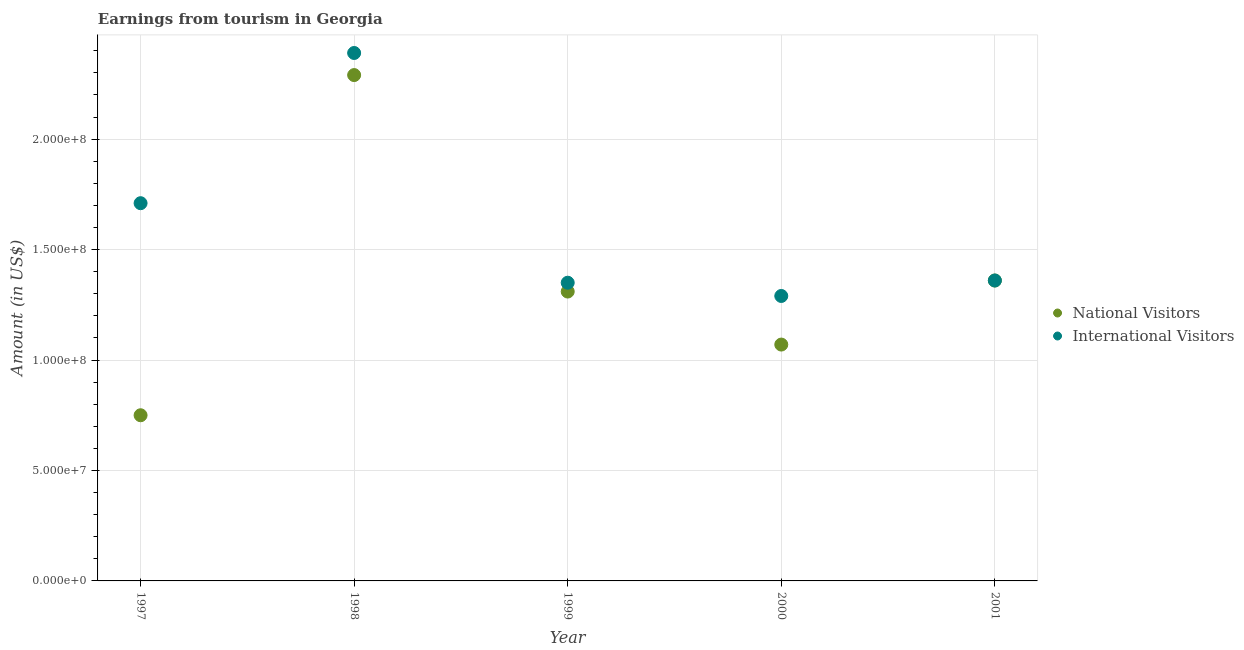How many different coloured dotlines are there?
Ensure brevity in your answer.  2. What is the amount earned from national visitors in 1999?
Give a very brief answer. 1.31e+08. Across all years, what is the maximum amount earned from national visitors?
Provide a succinct answer. 2.29e+08. Across all years, what is the minimum amount earned from international visitors?
Provide a succinct answer. 1.29e+08. In which year was the amount earned from international visitors maximum?
Your answer should be very brief. 1998. What is the total amount earned from international visitors in the graph?
Offer a very short reply. 8.10e+08. What is the difference between the amount earned from national visitors in 1997 and that in 2001?
Offer a very short reply. -6.10e+07. What is the difference between the amount earned from national visitors in 1999 and the amount earned from international visitors in 2000?
Keep it short and to the point. 2.00e+06. What is the average amount earned from national visitors per year?
Provide a short and direct response. 1.36e+08. In the year 1999, what is the difference between the amount earned from national visitors and amount earned from international visitors?
Ensure brevity in your answer.  -4.00e+06. What is the ratio of the amount earned from international visitors in 1997 to that in 1999?
Your response must be concise. 1.27. Is the difference between the amount earned from national visitors in 1997 and 1998 greater than the difference between the amount earned from international visitors in 1997 and 1998?
Ensure brevity in your answer.  No. What is the difference between the highest and the second highest amount earned from national visitors?
Your answer should be very brief. 9.30e+07. What is the difference between the highest and the lowest amount earned from international visitors?
Your answer should be very brief. 1.10e+08. In how many years, is the amount earned from international visitors greater than the average amount earned from international visitors taken over all years?
Provide a short and direct response. 2. Does the amount earned from national visitors monotonically increase over the years?
Offer a terse response. No. Is the amount earned from national visitors strictly greater than the amount earned from international visitors over the years?
Your response must be concise. No. Does the graph contain any zero values?
Provide a succinct answer. No. Where does the legend appear in the graph?
Your answer should be compact. Center right. What is the title of the graph?
Offer a very short reply. Earnings from tourism in Georgia. What is the label or title of the X-axis?
Offer a very short reply. Year. What is the Amount (in US$) in National Visitors in 1997?
Make the answer very short. 7.50e+07. What is the Amount (in US$) of International Visitors in 1997?
Provide a succinct answer. 1.71e+08. What is the Amount (in US$) in National Visitors in 1998?
Keep it short and to the point. 2.29e+08. What is the Amount (in US$) of International Visitors in 1998?
Keep it short and to the point. 2.39e+08. What is the Amount (in US$) in National Visitors in 1999?
Ensure brevity in your answer.  1.31e+08. What is the Amount (in US$) in International Visitors in 1999?
Keep it short and to the point. 1.35e+08. What is the Amount (in US$) of National Visitors in 2000?
Ensure brevity in your answer.  1.07e+08. What is the Amount (in US$) of International Visitors in 2000?
Your answer should be compact. 1.29e+08. What is the Amount (in US$) of National Visitors in 2001?
Your answer should be compact. 1.36e+08. What is the Amount (in US$) of International Visitors in 2001?
Your answer should be very brief. 1.36e+08. Across all years, what is the maximum Amount (in US$) in National Visitors?
Your response must be concise. 2.29e+08. Across all years, what is the maximum Amount (in US$) of International Visitors?
Offer a very short reply. 2.39e+08. Across all years, what is the minimum Amount (in US$) in National Visitors?
Your response must be concise. 7.50e+07. Across all years, what is the minimum Amount (in US$) in International Visitors?
Ensure brevity in your answer.  1.29e+08. What is the total Amount (in US$) of National Visitors in the graph?
Ensure brevity in your answer.  6.78e+08. What is the total Amount (in US$) in International Visitors in the graph?
Keep it short and to the point. 8.10e+08. What is the difference between the Amount (in US$) of National Visitors in 1997 and that in 1998?
Provide a short and direct response. -1.54e+08. What is the difference between the Amount (in US$) in International Visitors in 1997 and that in 1998?
Your answer should be very brief. -6.80e+07. What is the difference between the Amount (in US$) of National Visitors in 1997 and that in 1999?
Keep it short and to the point. -5.60e+07. What is the difference between the Amount (in US$) in International Visitors in 1997 and that in 1999?
Ensure brevity in your answer.  3.60e+07. What is the difference between the Amount (in US$) in National Visitors in 1997 and that in 2000?
Give a very brief answer. -3.20e+07. What is the difference between the Amount (in US$) in International Visitors in 1997 and that in 2000?
Offer a terse response. 4.20e+07. What is the difference between the Amount (in US$) in National Visitors in 1997 and that in 2001?
Keep it short and to the point. -6.10e+07. What is the difference between the Amount (in US$) in International Visitors in 1997 and that in 2001?
Keep it short and to the point. 3.50e+07. What is the difference between the Amount (in US$) in National Visitors in 1998 and that in 1999?
Ensure brevity in your answer.  9.80e+07. What is the difference between the Amount (in US$) of International Visitors in 1998 and that in 1999?
Provide a succinct answer. 1.04e+08. What is the difference between the Amount (in US$) of National Visitors in 1998 and that in 2000?
Ensure brevity in your answer.  1.22e+08. What is the difference between the Amount (in US$) of International Visitors in 1998 and that in 2000?
Offer a very short reply. 1.10e+08. What is the difference between the Amount (in US$) in National Visitors in 1998 and that in 2001?
Offer a terse response. 9.30e+07. What is the difference between the Amount (in US$) of International Visitors in 1998 and that in 2001?
Make the answer very short. 1.03e+08. What is the difference between the Amount (in US$) in National Visitors in 1999 and that in 2000?
Offer a very short reply. 2.40e+07. What is the difference between the Amount (in US$) in National Visitors in 1999 and that in 2001?
Give a very brief answer. -5.00e+06. What is the difference between the Amount (in US$) in International Visitors in 1999 and that in 2001?
Offer a very short reply. -1.00e+06. What is the difference between the Amount (in US$) in National Visitors in 2000 and that in 2001?
Provide a short and direct response. -2.90e+07. What is the difference between the Amount (in US$) of International Visitors in 2000 and that in 2001?
Offer a very short reply. -7.00e+06. What is the difference between the Amount (in US$) in National Visitors in 1997 and the Amount (in US$) in International Visitors in 1998?
Make the answer very short. -1.64e+08. What is the difference between the Amount (in US$) in National Visitors in 1997 and the Amount (in US$) in International Visitors in 1999?
Offer a very short reply. -6.00e+07. What is the difference between the Amount (in US$) of National Visitors in 1997 and the Amount (in US$) of International Visitors in 2000?
Your answer should be compact. -5.40e+07. What is the difference between the Amount (in US$) in National Visitors in 1997 and the Amount (in US$) in International Visitors in 2001?
Make the answer very short. -6.10e+07. What is the difference between the Amount (in US$) of National Visitors in 1998 and the Amount (in US$) of International Visitors in 1999?
Ensure brevity in your answer.  9.40e+07. What is the difference between the Amount (in US$) in National Visitors in 1998 and the Amount (in US$) in International Visitors in 2001?
Provide a succinct answer. 9.30e+07. What is the difference between the Amount (in US$) of National Visitors in 1999 and the Amount (in US$) of International Visitors in 2001?
Offer a very short reply. -5.00e+06. What is the difference between the Amount (in US$) of National Visitors in 2000 and the Amount (in US$) of International Visitors in 2001?
Keep it short and to the point. -2.90e+07. What is the average Amount (in US$) in National Visitors per year?
Your response must be concise. 1.36e+08. What is the average Amount (in US$) of International Visitors per year?
Keep it short and to the point. 1.62e+08. In the year 1997, what is the difference between the Amount (in US$) in National Visitors and Amount (in US$) in International Visitors?
Give a very brief answer. -9.60e+07. In the year 1998, what is the difference between the Amount (in US$) of National Visitors and Amount (in US$) of International Visitors?
Your response must be concise. -1.00e+07. In the year 2000, what is the difference between the Amount (in US$) of National Visitors and Amount (in US$) of International Visitors?
Ensure brevity in your answer.  -2.20e+07. What is the ratio of the Amount (in US$) in National Visitors in 1997 to that in 1998?
Make the answer very short. 0.33. What is the ratio of the Amount (in US$) in International Visitors in 1997 to that in 1998?
Provide a short and direct response. 0.72. What is the ratio of the Amount (in US$) of National Visitors in 1997 to that in 1999?
Provide a short and direct response. 0.57. What is the ratio of the Amount (in US$) in International Visitors in 1997 to that in 1999?
Your response must be concise. 1.27. What is the ratio of the Amount (in US$) in National Visitors in 1997 to that in 2000?
Your response must be concise. 0.7. What is the ratio of the Amount (in US$) in International Visitors in 1997 to that in 2000?
Your answer should be compact. 1.33. What is the ratio of the Amount (in US$) of National Visitors in 1997 to that in 2001?
Make the answer very short. 0.55. What is the ratio of the Amount (in US$) of International Visitors in 1997 to that in 2001?
Give a very brief answer. 1.26. What is the ratio of the Amount (in US$) in National Visitors in 1998 to that in 1999?
Give a very brief answer. 1.75. What is the ratio of the Amount (in US$) of International Visitors in 1998 to that in 1999?
Offer a very short reply. 1.77. What is the ratio of the Amount (in US$) of National Visitors in 1998 to that in 2000?
Your answer should be very brief. 2.14. What is the ratio of the Amount (in US$) in International Visitors in 1998 to that in 2000?
Your answer should be compact. 1.85. What is the ratio of the Amount (in US$) of National Visitors in 1998 to that in 2001?
Provide a short and direct response. 1.68. What is the ratio of the Amount (in US$) of International Visitors in 1998 to that in 2001?
Keep it short and to the point. 1.76. What is the ratio of the Amount (in US$) in National Visitors in 1999 to that in 2000?
Offer a very short reply. 1.22. What is the ratio of the Amount (in US$) of International Visitors in 1999 to that in 2000?
Provide a short and direct response. 1.05. What is the ratio of the Amount (in US$) in National Visitors in 1999 to that in 2001?
Your response must be concise. 0.96. What is the ratio of the Amount (in US$) in National Visitors in 2000 to that in 2001?
Offer a very short reply. 0.79. What is the ratio of the Amount (in US$) of International Visitors in 2000 to that in 2001?
Provide a succinct answer. 0.95. What is the difference between the highest and the second highest Amount (in US$) in National Visitors?
Your answer should be compact. 9.30e+07. What is the difference between the highest and the second highest Amount (in US$) of International Visitors?
Your answer should be very brief. 6.80e+07. What is the difference between the highest and the lowest Amount (in US$) in National Visitors?
Offer a very short reply. 1.54e+08. What is the difference between the highest and the lowest Amount (in US$) in International Visitors?
Your answer should be compact. 1.10e+08. 